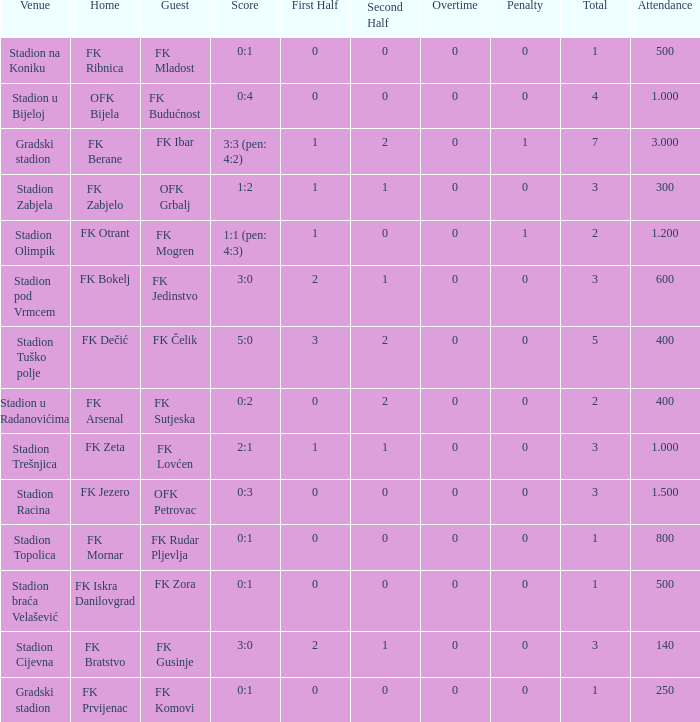What was the attendance of the game that had an away team of FK Mogren? 1.2. 